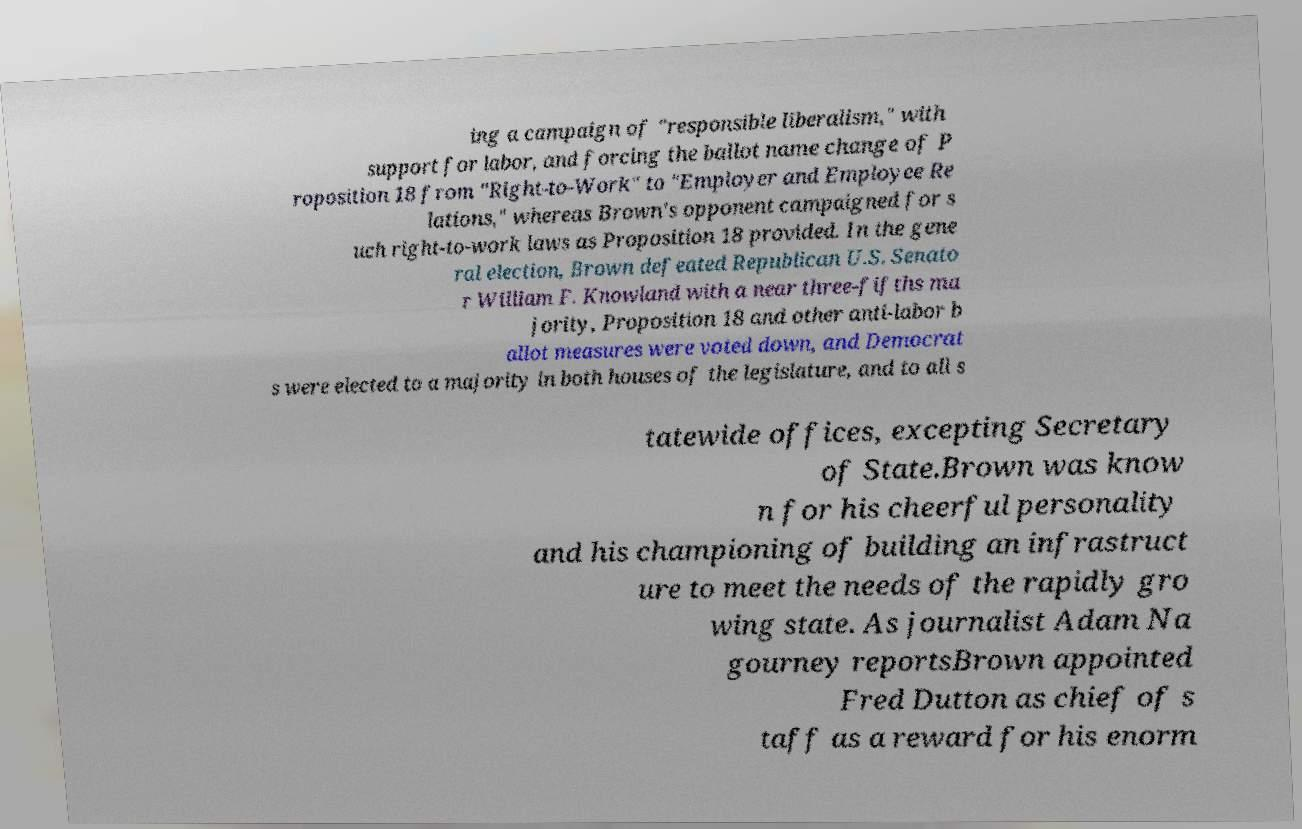Can you read and provide the text displayed in the image?This photo seems to have some interesting text. Can you extract and type it out for me? ing a campaign of "responsible liberalism," with support for labor, and forcing the ballot name change of P roposition 18 from "Right-to-Work" to "Employer and Employee Re lations," whereas Brown's opponent campaigned for s uch right-to-work laws as Proposition 18 provided. In the gene ral election, Brown defeated Republican U.S. Senato r William F. Knowland with a near three-fifths ma jority, Proposition 18 and other anti-labor b allot measures were voted down, and Democrat s were elected to a majority in both houses of the legislature, and to all s tatewide offices, excepting Secretary of State.Brown was know n for his cheerful personality and his championing of building an infrastruct ure to meet the needs of the rapidly gro wing state. As journalist Adam Na gourney reportsBrown appointed Fred Dutton as chief of s taff as a reward for his enorm 